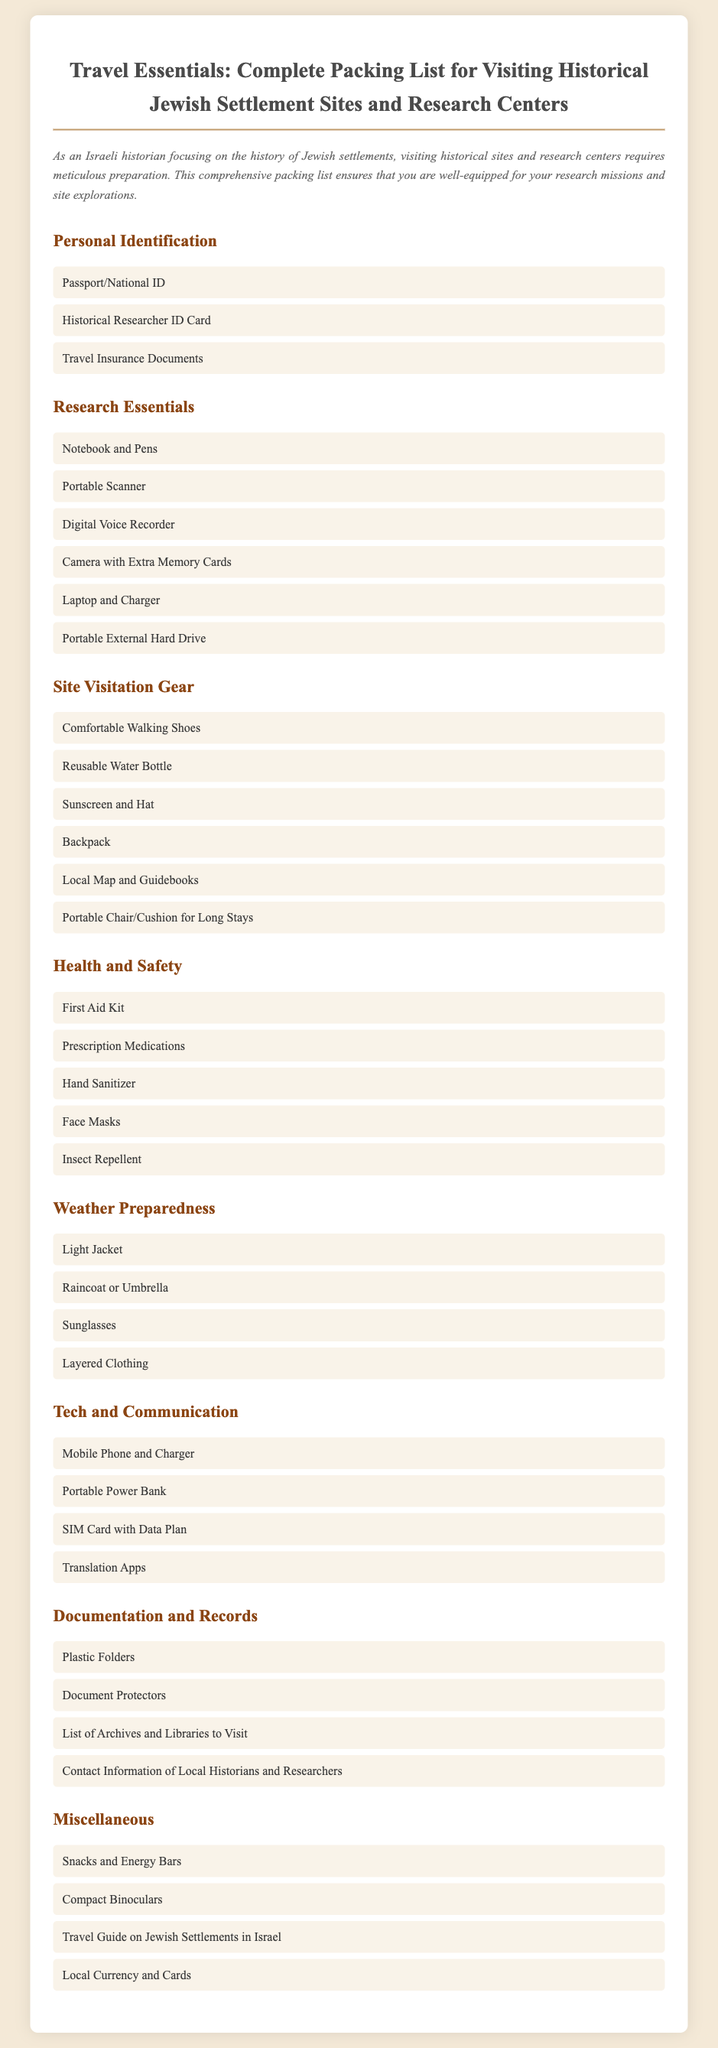what type of document is this? The document is a packing list designed for those visiting historical Jewish settlement sites and research centers.
Answer: Packing list how many categories are listed in the document? There are seven categories that detail various items to pack.
Answer: Seven what should you bring for health and safety? The health and safety section includes items related to maintaining personal well-being while traveling.
Answer: First Aid Kit which item is suggested for weather preparedness? The weather preparedness category includes items suitable for various weather conditions.
Answer: Light Jacket what technology item is recommended for communication? The document lists technology essentials that support communication during the travels.
Answer: Mobile Phone and Charger what is one research essential mentioned in the packing list? Research essentials include items crucial for conducting historical research effectively at sites.
Answer: Notebook and Pens which category includes snacks? The miscellaneous category covers various additional items that travelers might need.
Answer: Miscellaneous what might you need for site visitation? The site visitation gear section lists items necessary for comfort and navigation at historical locations.
Answer: Comfortable Walking Shoes which item helps with document protection? Document protection is addressed in the documentation and records section, which focuses on safeguarding important papers.
Answer: Document Protectors 